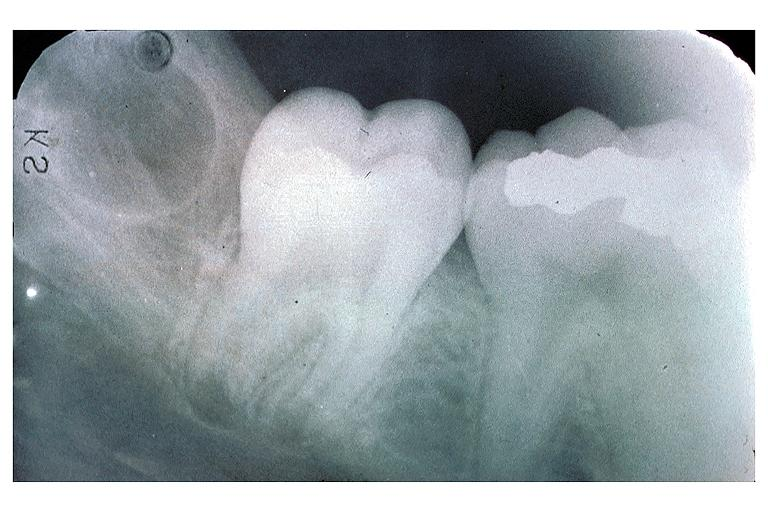what does this image show?
Answer the question using a single word or phrase. Developing 3rd molar 